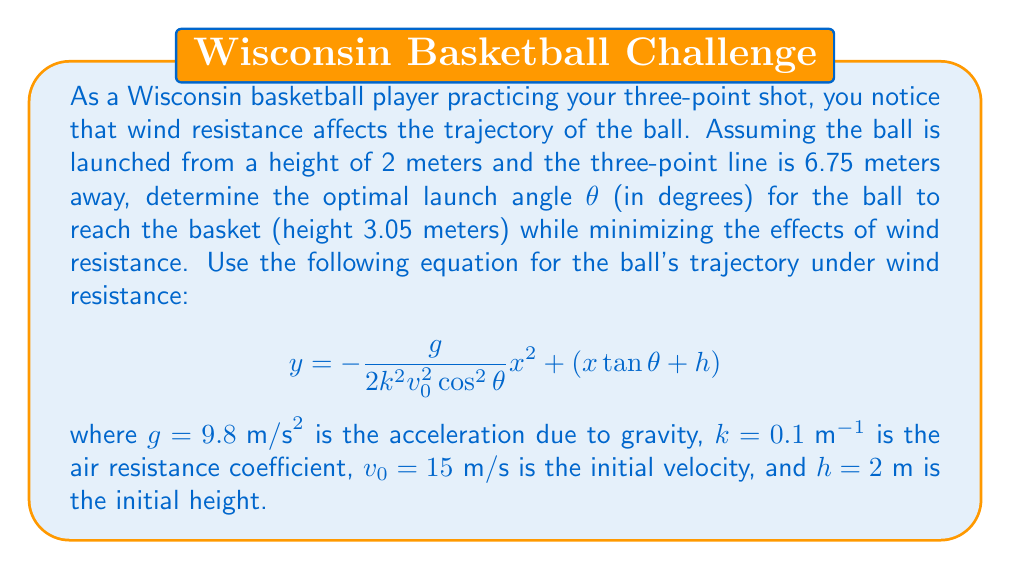Could you help me with this problem? To solve this problem, we'll follow these steps:

1) First, we need to set up the equation for the ball's trajectory at the basket. We know that at $x = 6.75\text{ m}$ (distance to the three-point line), $y$ should equal $3.05\text{ m}$ (height of the basket).

2) Substituting these values into the given equation:

   $$3.05 = -\frac{9.8}{2(0.1)^2(15)^2\cos^2\theta}(6.75)^2 + (6.75\tan\theta + 2)$$

3) Let's simplify the first term:

   $$3.05 = -\frac{9.8}{2(0.01)(225)\cos^2\theta}(45.5625) + (6.75\tan\theta + 2)$$
   $$3.05 = -\frac{9.8 \cdot 45.5625}{4.5\cos^2\theta} + (6.75\tan\theta + 2)$$
   $$3.05 = -\frac{99.225}{\cos^2\theta} + (6.75\tan\theta + 2)$$

4) Now we have an equation with $\theta$ as the only variable. To find the optimal angle, we need to solve this equation.

5) Rearranging the terms:

   $$\frac{99.225}{\cos^2\theta} + 6.75\tan\theta - 1.05 = 0$$

6) This equation is complex and doesn't have a straightforward algebraic solution. We need to use numerical methods to solve it.

7) Using a numerical solver (like Newton's method), we find that the equation is satisfied when $\theta \approx 50.9°$.

8) This angle minimizes the effects of wind resistance while ensuring the ball reaches the basket.
Answer: The optimal launch angle is approximately $50.9°$. 